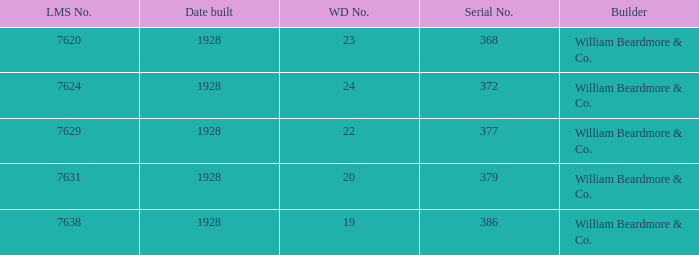Name the total number of wd number for lms number being 7638 1.0. 